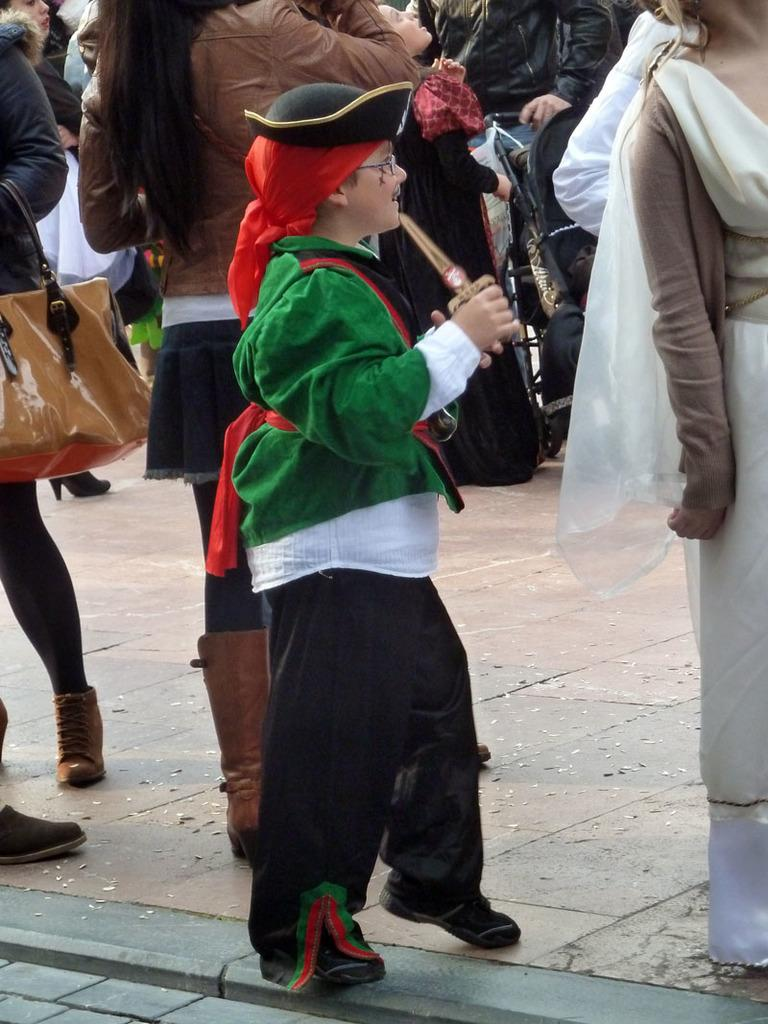Where was the image taken? The image was taken on a street. What can be seen in the foreground of the image? There is a kid in the foreground of the image. Can you describe the person on the right side of the image? There is a person on the right side of the image. What is happening on the left side of the image? There are people on the left side of the image. What is visible in the background of the image? There is a group of people in the background of the image. What type of coal is being used by the kid in the image? There is no coal present in the image; it features a kid on a street with other people. Can you see a branch in the hands of the person on the right side of the image? There is no branch visible in the hands of the person on the right side of the image. 